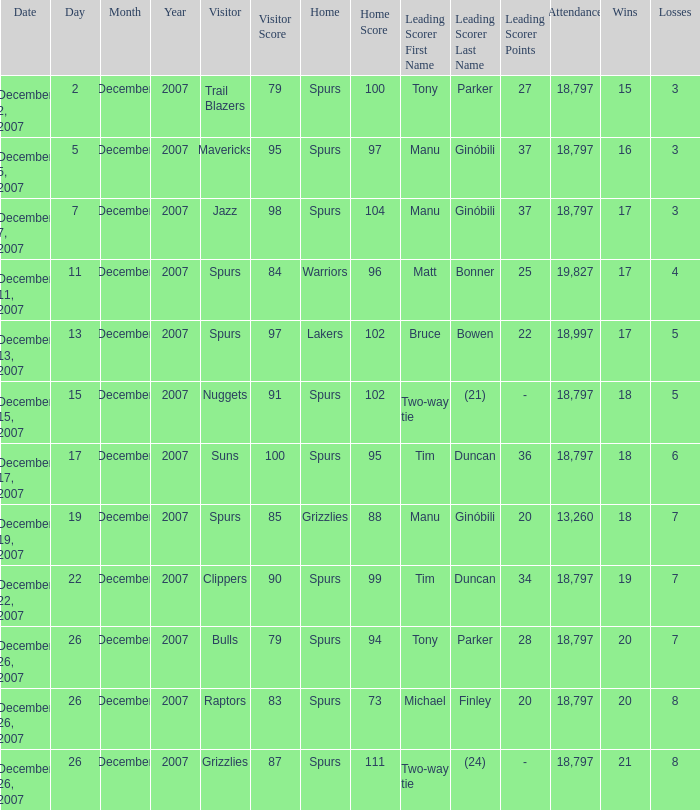What is the highest attendace of the game with the Lakers as the home team? 18997.0. 